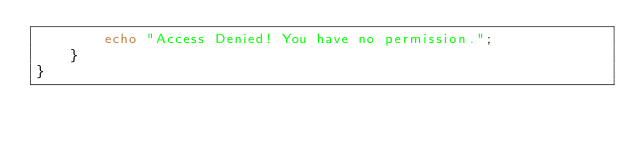Convert code to text. <code><loc_0><loc_0><loc_500><loc_500><_PHP_>        echo "Access Denied! You have no permission.";
    }
}
</code> 